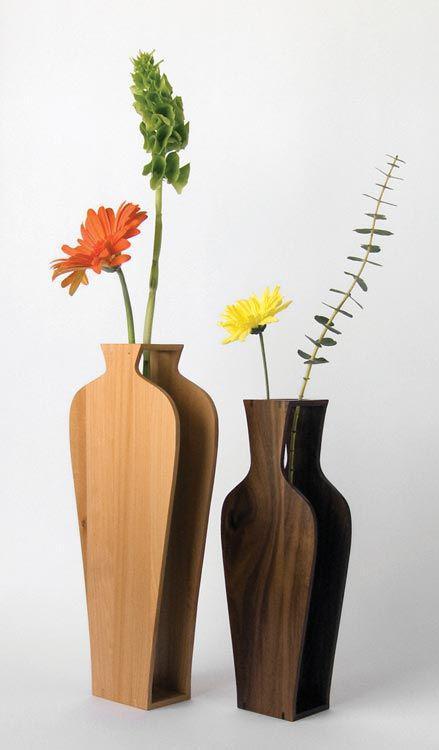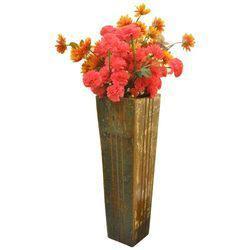The first image is the image on the left, the second image is the image on the right. Assess this claim about the two images: "There is one empty vase in the image on the right.". Correct or not? Answer yes or no. No. The first image is the image on the left, the second image is the image on the right. Given the left and right images, does the statement "In one image, a single vase has four box-like sides that are smaller at the bottom than at the top, while one vase in a second image is dark brown and curved." hold true? Answer yes or no. Yes. 